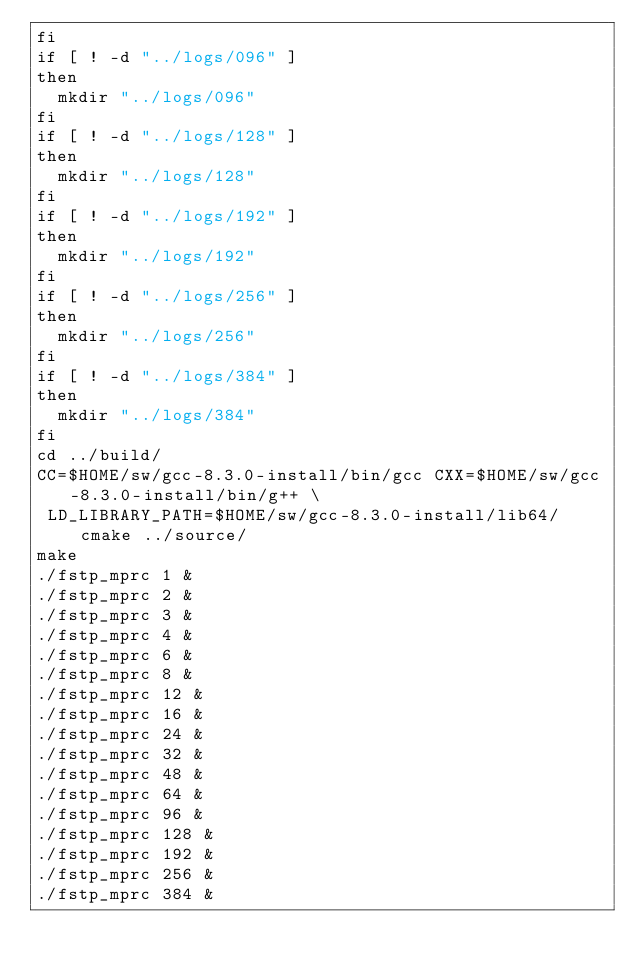<code> <loc_0><loc_0><loc_500><loc_500><_Bash_>fi
if [ ! -d "../logs/096" ]
then
  mkdir "../logs/096"
fi
if [ ! -d "../logs/128" ]
then
  mkdir "../logs/128"
fi
if [ ! -d "../logs/192" ]
then
  mkdir "../logs/192"
fi
if [ ! -d "../logs/256" ]
then
  mkdir "../logs/256"
fi
if [ ! -d "../logs/384" ]
then
  mkdir "../logs/384"
fi
cd ../build/
CC=$HOME/sw/gcc-8.3.0-install/bin/gcc CXX=$HOME/sw/gcc-8.3.0-install/bin/g++ \
 LD_LIBRARY_PATH=$HOME/sw/gcc-8.3.0-install/lib64/ cmake ../source/
make
./fstp_mprc 1 &
./fstp_mprc 2 &
./fstp_mprc 3 &
./fstp_mprc 4 &
./fstp_mprc 6 &
./fstp_mprc 8 &
./fstp_mprc 12 &
./fstp_mprc 16 &
./fstp_mprc 24 &
./fstp_mprc 32 &
./fstp_mprc 48 &
./fstp_mprc 64 &
./fstp_mprc 96 &
./fstp_mprc 128 &
./fstp_mprc 192 &
./fstp_mprc 256 &
./fstp_mprc 384 &
</code> 